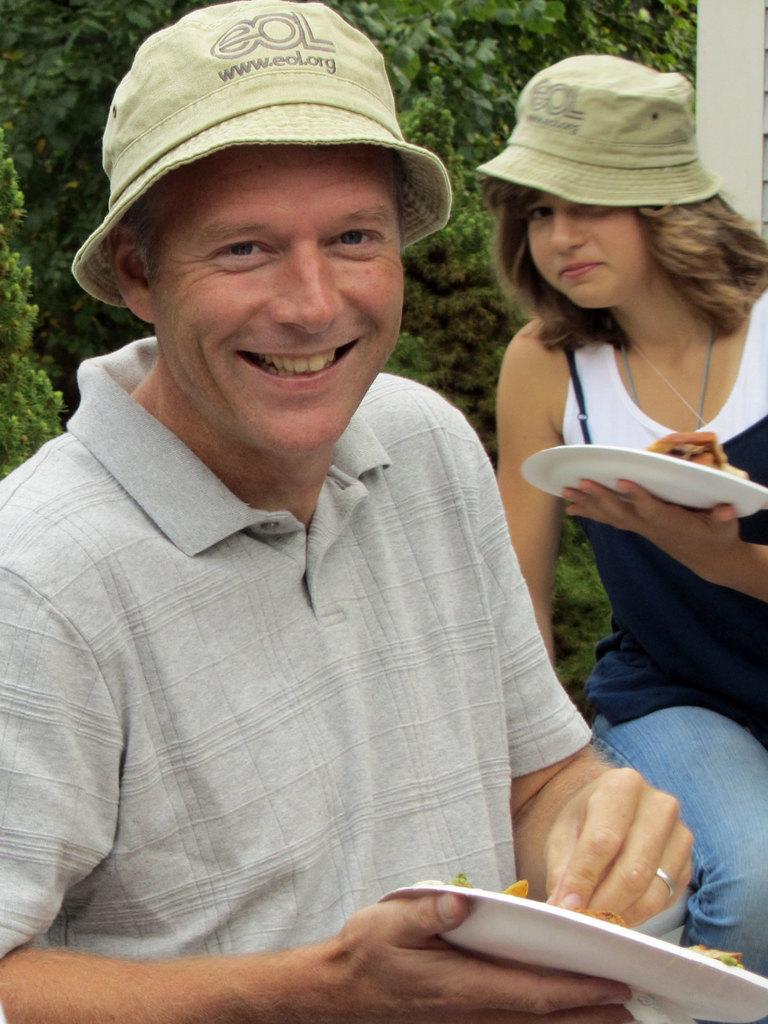Please provide a concise description of this image. This image is taken outdoors. In the background there are many plants. On the left side of the image a man is holding a plate with a food item in his hands and he is with a smiling face. On the right side of the image a woman is sitting and she is holding a plate in her hand. 